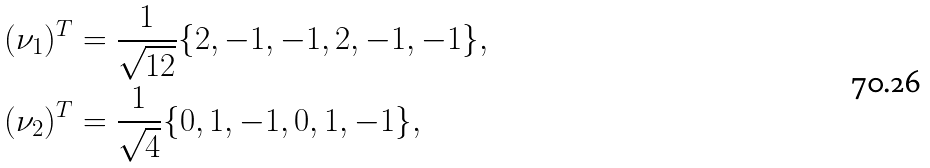<formula> <loc_0><loc_0><loc_500><loc_500>( \nu _ { 1 } ) ^ { T } & = \frac { 1 } { \sqrt { 1 2 } } \{ 2 , - 1 , - 1 , 2 , - 1 , - 1 \} , \\ ( \nu _ { 2 } ) ^ { T } & = \frac { 1 } { \sqrt { 4 } } \{ 0 , 1 , - 1 , 0 , 1 , - 1 \} ,</formula> 